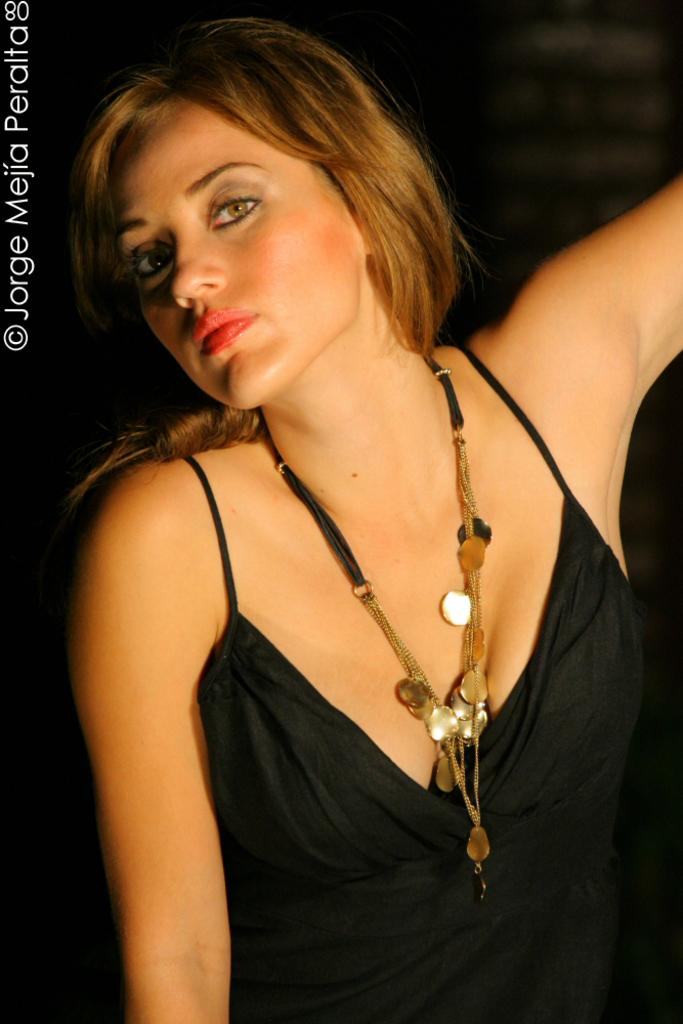Who is the main subject in the image? There is a woman in the image. What is the woman wearing? The woman is wearing a black dress. How many letters are visible on the woman's heart in the image? There are no letters visible on the woman's heart in the image, as she is not depicted with a heart or any letters. 